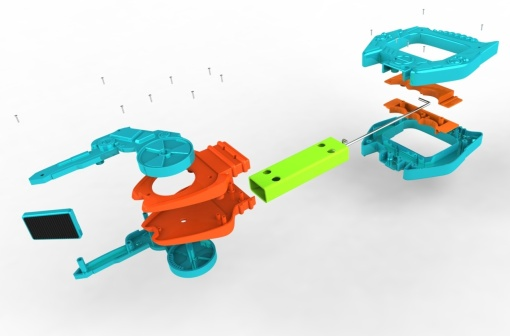Can you describe the most striking feature of this image? The most striking feature of this image is the vibrant contrast between the orange and green colors of the toy car components. This color scheme not only enhances the visual appeal but also adds a playful and energetic vibe to the scene. What role do you think the floating screws play in the narrative of this image? The floating screws significantly contribute to the narrative by suggesting an ongoing process, either of assembly or disassembly. They imbue the image with a sense of movement and indicate careful, precise work underway, emphasizing the intricacy and meticulous nature of putting together or taking apart the toy car. 